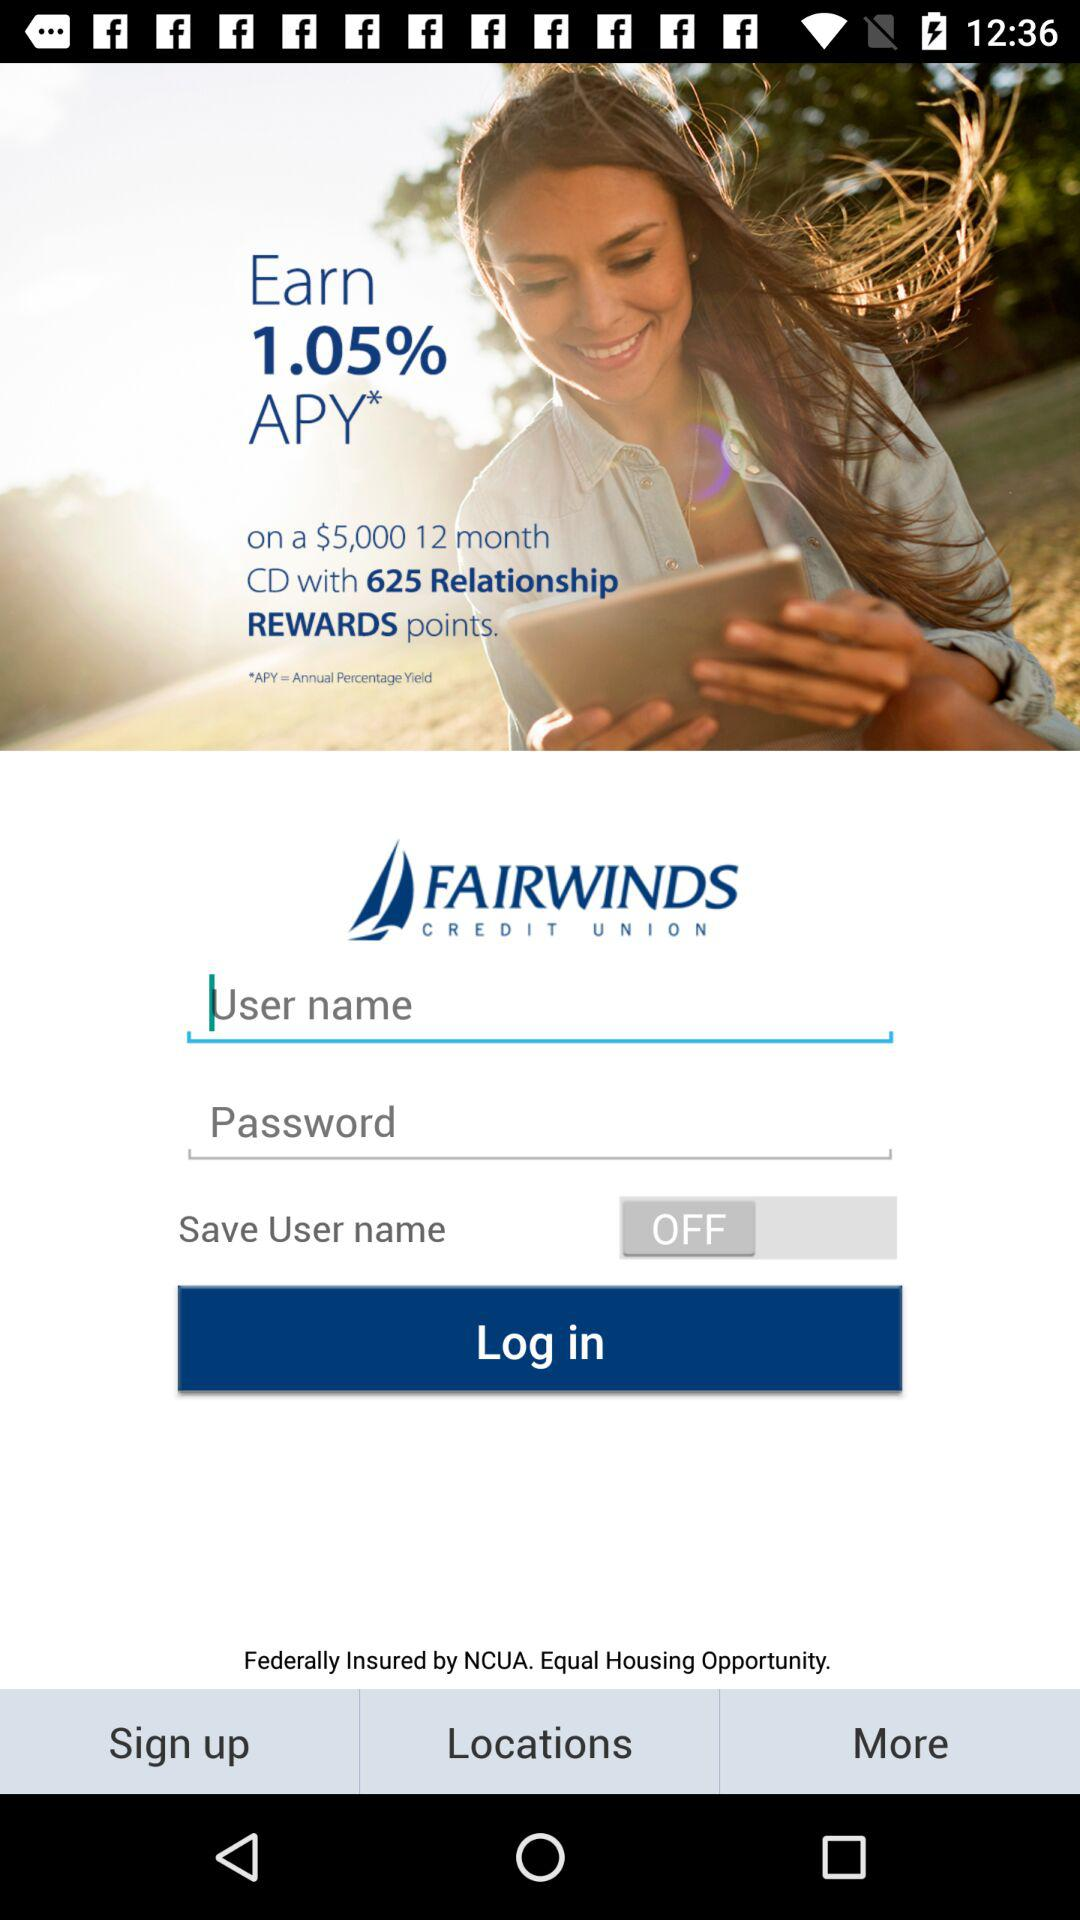How many relationship reward points can be earned? The number of relationship reward points that can be earned is 625. 